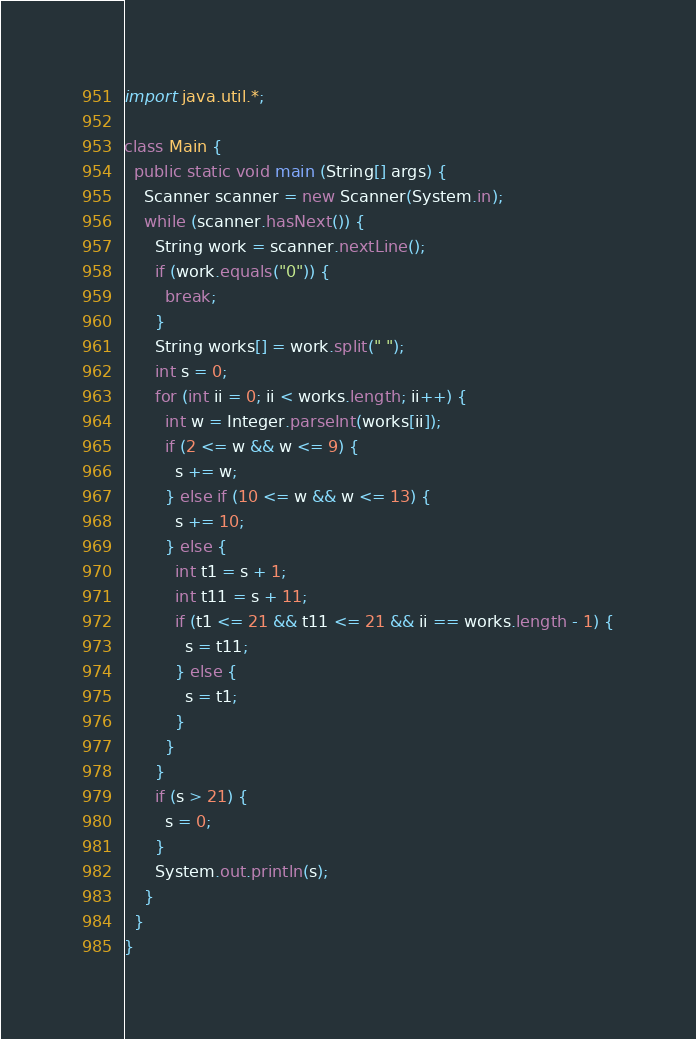Convert code to text. <code><loc_0><loc_0><loc_500><loc_500><_Java_>import java.util.*;

class Main {
  public static void main (String[] args) {
    Scanner scanner = new Scanner(System.in);
    while (scanner.hasNext()) {
      String work = scanner.nextLine();
      if (work.equals("0")) {
        break;
      }
      String works[] = work.split(" ");
      int s = 0;
      for (int ii = 0; ii < works.length; ii++) {
        int w = Integer.parseInt(works[ii]);
        if (2 <= w && w <= 9) {
          s += w;
        } else if (10 <= w && w <= 13) {
          s += 10;
        } else {
          int t1 = s + 1;
          int t11 = s + 11;
          if (t1 <= 21 && t11 <= 21 && ii == works.length - 1) {
            s = t11;
          } else {
            s = t1;
          }
        }
      }
      if (s > 21) {
        s = 0;
      }
      System.out.println(s);
    }
  }
}</code> 